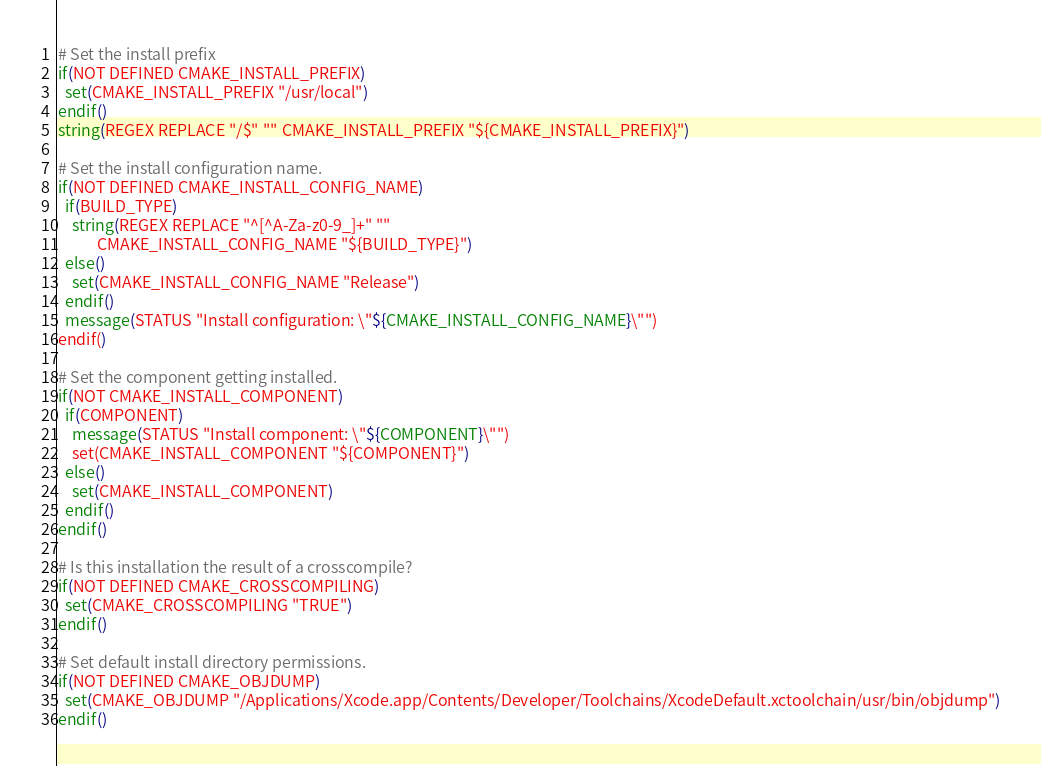Convert code to text. <code><loc_0><loc_0><loc_500><loc_500><_CMake_>
# Set the install prefix
if(NOT DEFINED CMAKE_INSTALL_PREFIX)
  set(CMAKE_INSTALL_PREFIX "/usr/local")
endif()
string(REGEX REPLACE "/$" "" CMAKE_INSTALL_PREFIX "${CMAKE_INSTALL_PREFIX}")

# Set the install configuration name.
if(NOT DEFINED CMAKE_INSTALL_CONFIG_NAME)
  if(BUILD_TYPE)
    string(REGEX REPLACE "^[^A-Za-z0-9_]+" ""
           CMAKE_INSTALL_CONFIG_NAME "${BUILD_TYPE}")
  else()
    set(CMAKE_INSTALL_CONFIG_NAME "Release")
  endif()
  message(STATUS "Install configuration: \"${CMAKE_INSTALL_CONFIG_NAME}\"")
endif()

# Set the component getting installed.
if(NOT CMAKE_INSTALL_COMPONENT)
  if(COMPONENT)
    message(STATUS "Install component: \"${COMPONENT}\"")
    set(CMAKE_INSTALL_COMPONENT "${COMPONENT}")
  else()
    set(CMAKE_INSTALL_COMPONENT)
  endif()
endif()

# Is this installation the result of a crosscompile?
if(NOT DEFINED CMAKE_CROSSCOMPILING)
  set(CMAKE_CROSSCOMPILING "TRUE")
endif()

# Set default install directory permissions.
if(NOT DEFINED CMAKE_OBJDUMP)
  set(CMAKE_OBJDUMP "/Applications/Xcode.app/Contents/Developer/Toolchains/XcodeDefault.xctoolchain/usr/bin/objdump")
endif()

</code> 